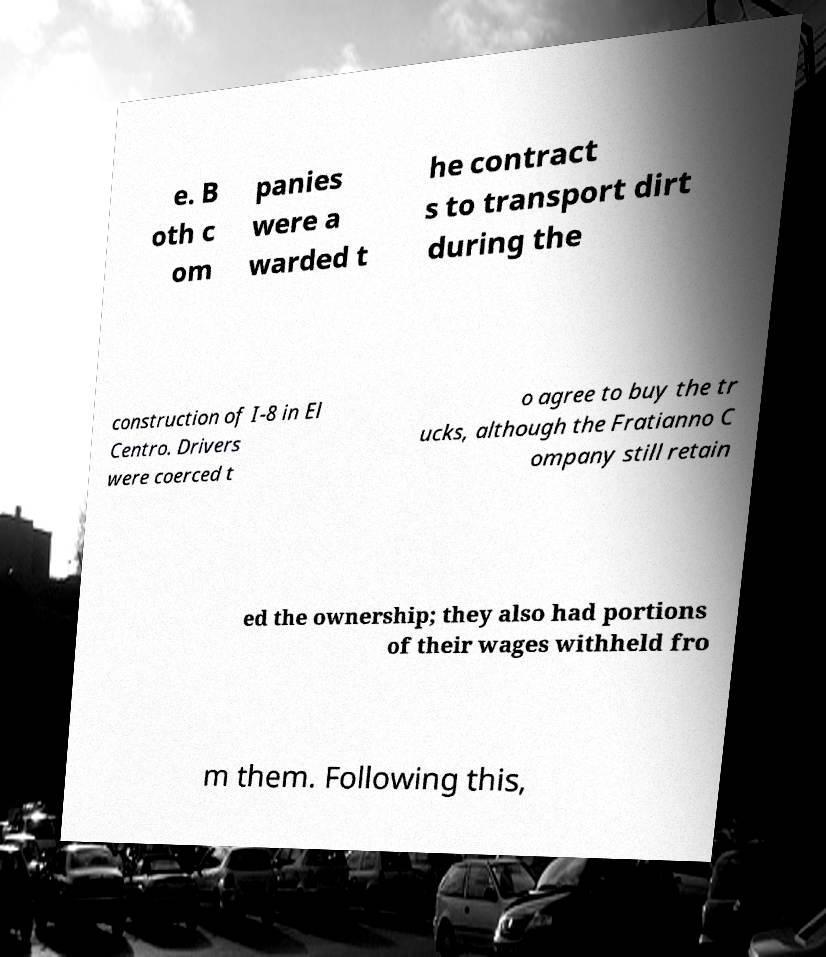Please read and relay the text visible in this image. What does it say? e. B oth c om panies were a warded t he contract s to transport dirt during the construction of I-8 in El Centro. Drivers were coerced t o agree to buy the tr ucks, although the Fratianno C ompany still retain ed the ownership; they also had portions of their wages withheld fro m them. Following this, 